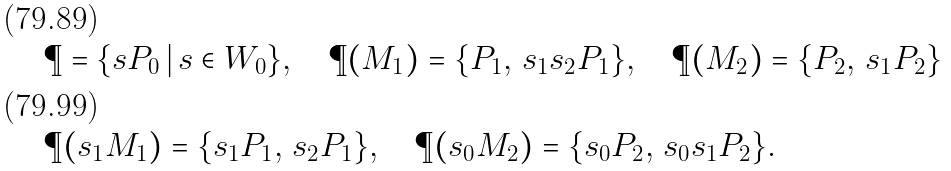<formula> <loc_0><loc_0><loc_500><loc_500>& \P = \{ s P _ { 0 } \, | \, s \in W _ { 0 } \} , \quad \P ( M _ { 1 } ) = \{ P _ { 1 } , \, s _ { 1 } s _ { 2 } P _ { 1 } \} , \quad \P ( M _ { 2 } ) = \{ P _ { 2 } , \, s _ { 1 } P _ { 2 } \} \\ & \P ( s _ { 1 } M _ { 1 } ) = \{ s _ { 1 } P _ { 1 } , \, s _ { 2 } P _ { 1 } \} , \quad \P ( s _ { 0 } M _ { 2 } ) = \{ s _ { 0 } P _ { 2 } , \, s _ { 0 } s _ { 1 } P _ { 2 } \} .</formula> 